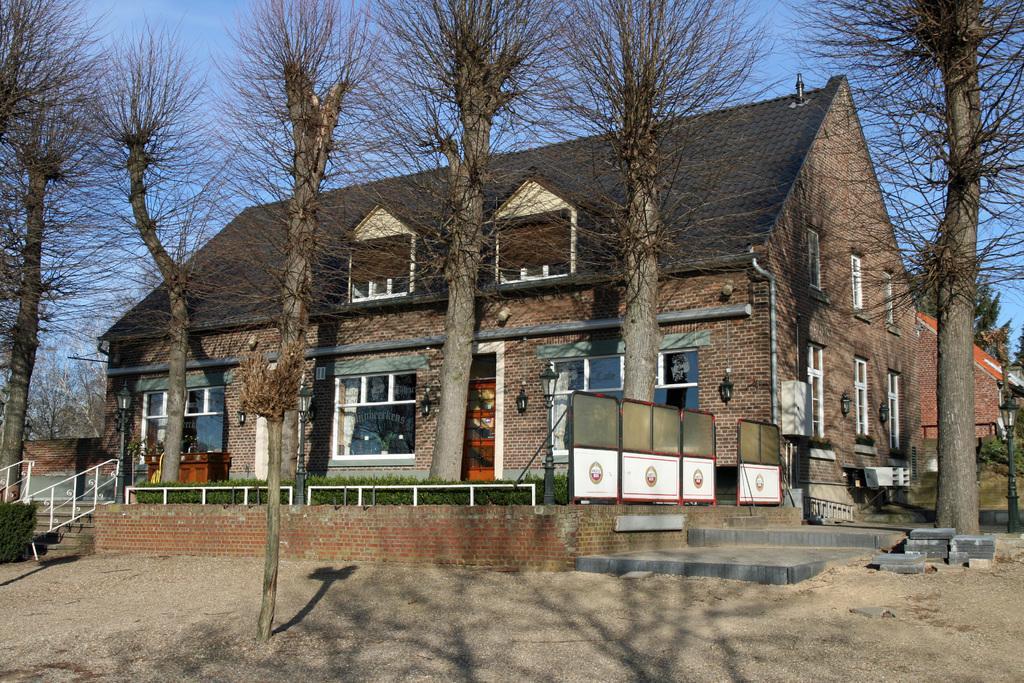Please provide a concise description of this image. This picture shows a building and we see trees and few lights to the wall and we see glass windows and a plant and we see stars and a blue sky. 